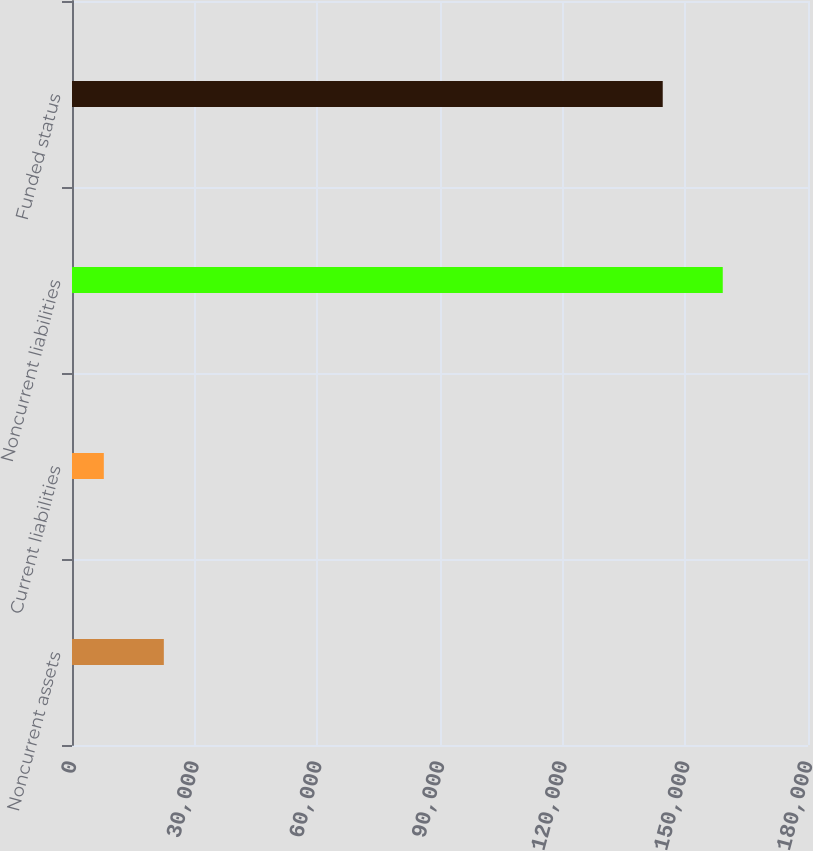<chart> <loc_0><loc_0><loc_500><loc_500><bar_chart><fcel>Noncurrent assets<fcel>Current liabilities<fcel>Noncurrent liabilities<fcel>Funded status<nl><fcel>22459.4<fcel>7782<fcel>159151<fcel>144474<nl></chart> 